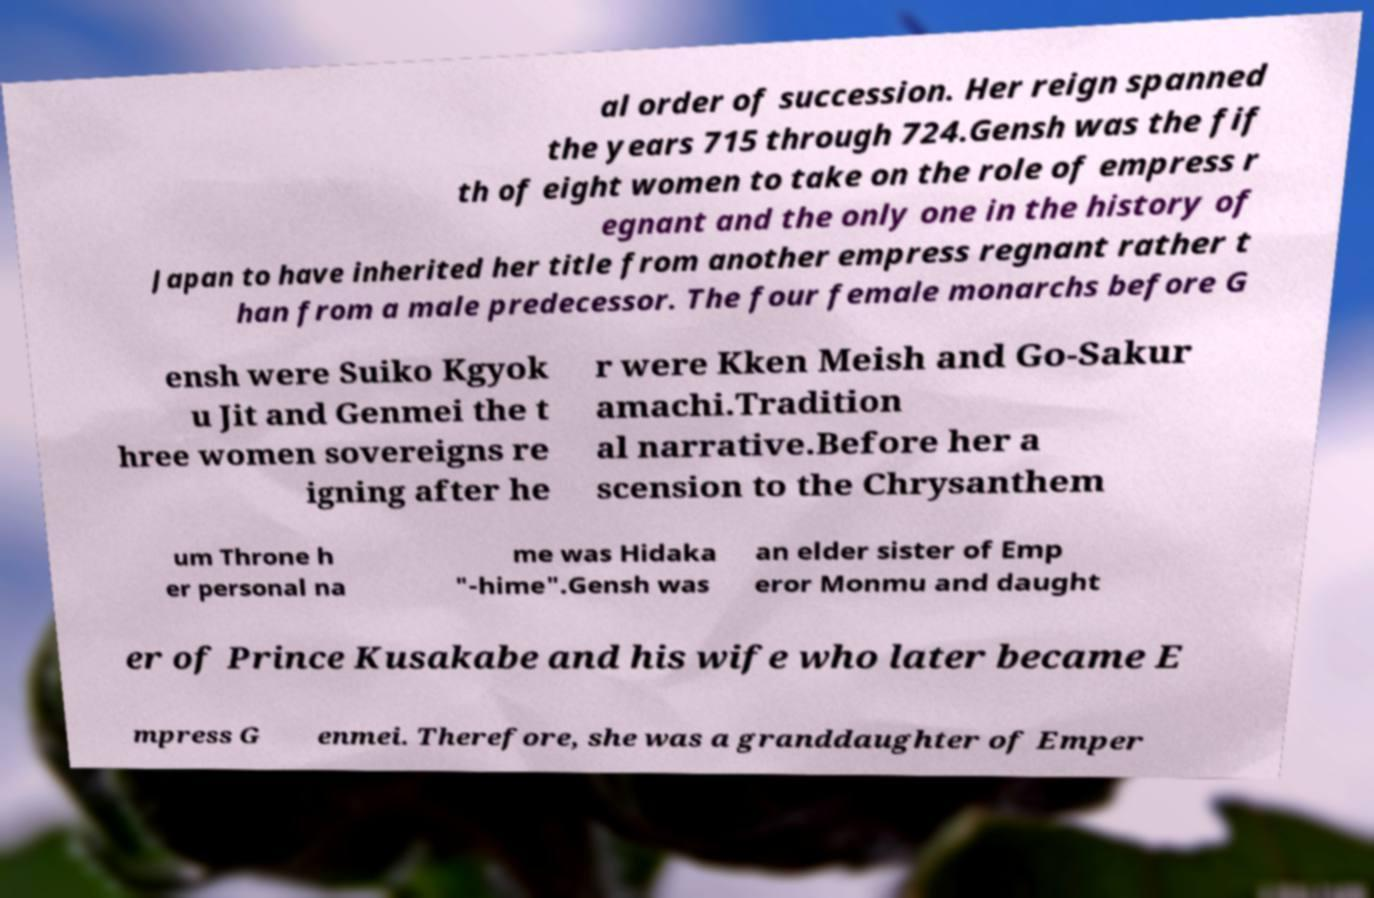Could you extract and type out the text from this image? al order of succession. Her reign spanned the years 715 through 724.Gensh was the fif th of eight women to take on the role of empress r egnant and the only one in the history of Japan to have inherited her title from another empress regnant rather t han from a male predecessor. The four female monarchs before G ensh were Suiko Kgyok u Jit and Genmei the t hree women sovereigns re igning after he r were Kken Meish and Go-Sakur amachi.Tradition al narrative.Before her a scension to the Chrysanthem um Throne h er personal na me was Hidaka "-hime".Gensh was an elder sister of Emp eror Monmu and daught er of Prince Kusakabe and his wife who later became E mpress G enmei. Therefore, she was a granddaughter of Emper 